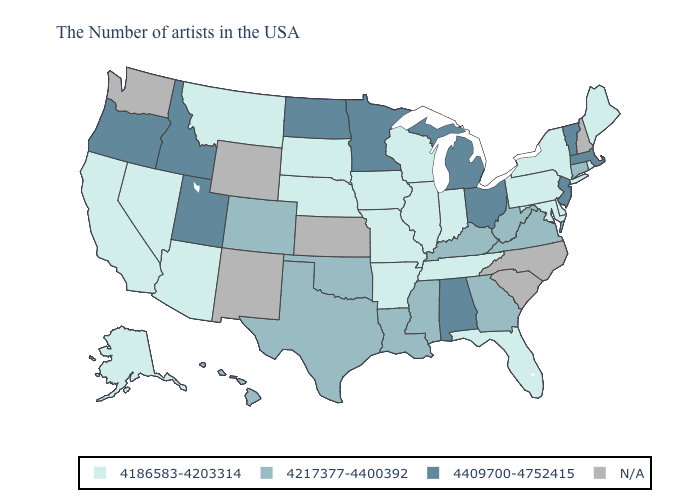Does Nevada have the highest value in the West?
Write a very short answer. No. How many symbols are there in the legend?
Concise answer only. 4. What is the highest value in the USA?
Quick response, please. 4409700-4752415. Does Virginia have the lowest value in the USA?
Quick response, please. No. What is the value of Iowa?
Short answer required. 4186583-4203314. Does the first symbol in the legend represent the smallest category?
Answer briefly. Yes. Is the legend a continuous bar?
Give a very brief answer. No. Name the states that have a value in the range 4409700-4752415?
Short answer required. Massachusetts, Vermont, New Jersey, Ohio, Michigan, Alabama, Minnesota, North Dakota, Utah, Idaho, Oregon. Is the legend a continuous bar?
Quick response, please. No. Does Montana have the lowest value in the USA?
Short answer required. Yes. Is the legend a continuous bar?
Quick response, please. No. Name the states that have a value in the range 4186583-4203314?
Keep it brief. Maine, Rhode Island, New York, Delaware, Maryland, Pennsylvania, Florida, Indiana, Tennessee, Wisconsin, Illinois, Missouri, Arkansas, Iowa, Nebraska, South Dakota, Montana, Arizona, Nevada, California, Alaska. What is the value of Alaska?
Short answer required. 4186583-4203314. Name the states that have a value in the range N/A?
Write a very short answer. New Hampshire, North Carolina, South Carolina, Kansas, Wyoming, New Mexico, Washington. 